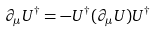Convert formula to latex. <formula><loc_0><loc_0><loc_500><loc_500>\partial _ { \mu } U ^ { \dag } = - U ^ { \dag } ( \partial _ { \mu } U ) U ^ { \dag }</formula> 